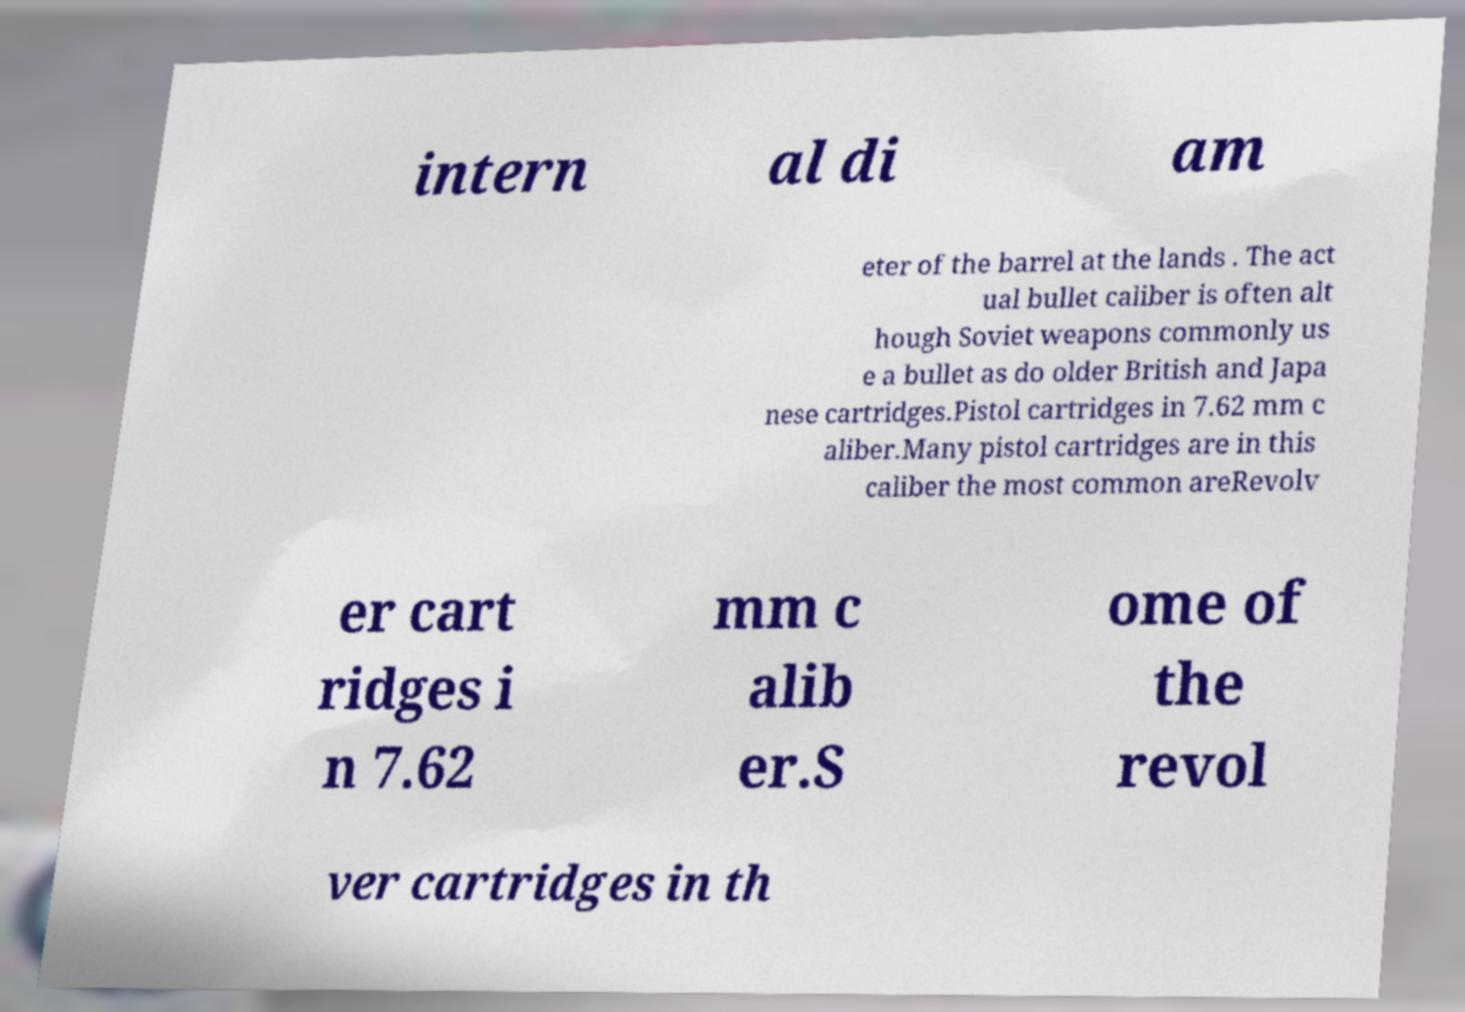Can you read and provide the text displayed in the image?This photo seems to have some interesting text. Can you extract and type it out for me? intern al di am eter of the barrel at the lands . The act ual bullet caliber is often alt hough Soviet weapons commonly us e a bullet as do older British and Japa nese cartridges.Pistol cartridges in 7.62 mm c aliber.Many pistol cartridges are in this caliber the most common areRevolv er cart ridges i n 7.62 mm c alib er.S ome of the revol ver cartridges in th 